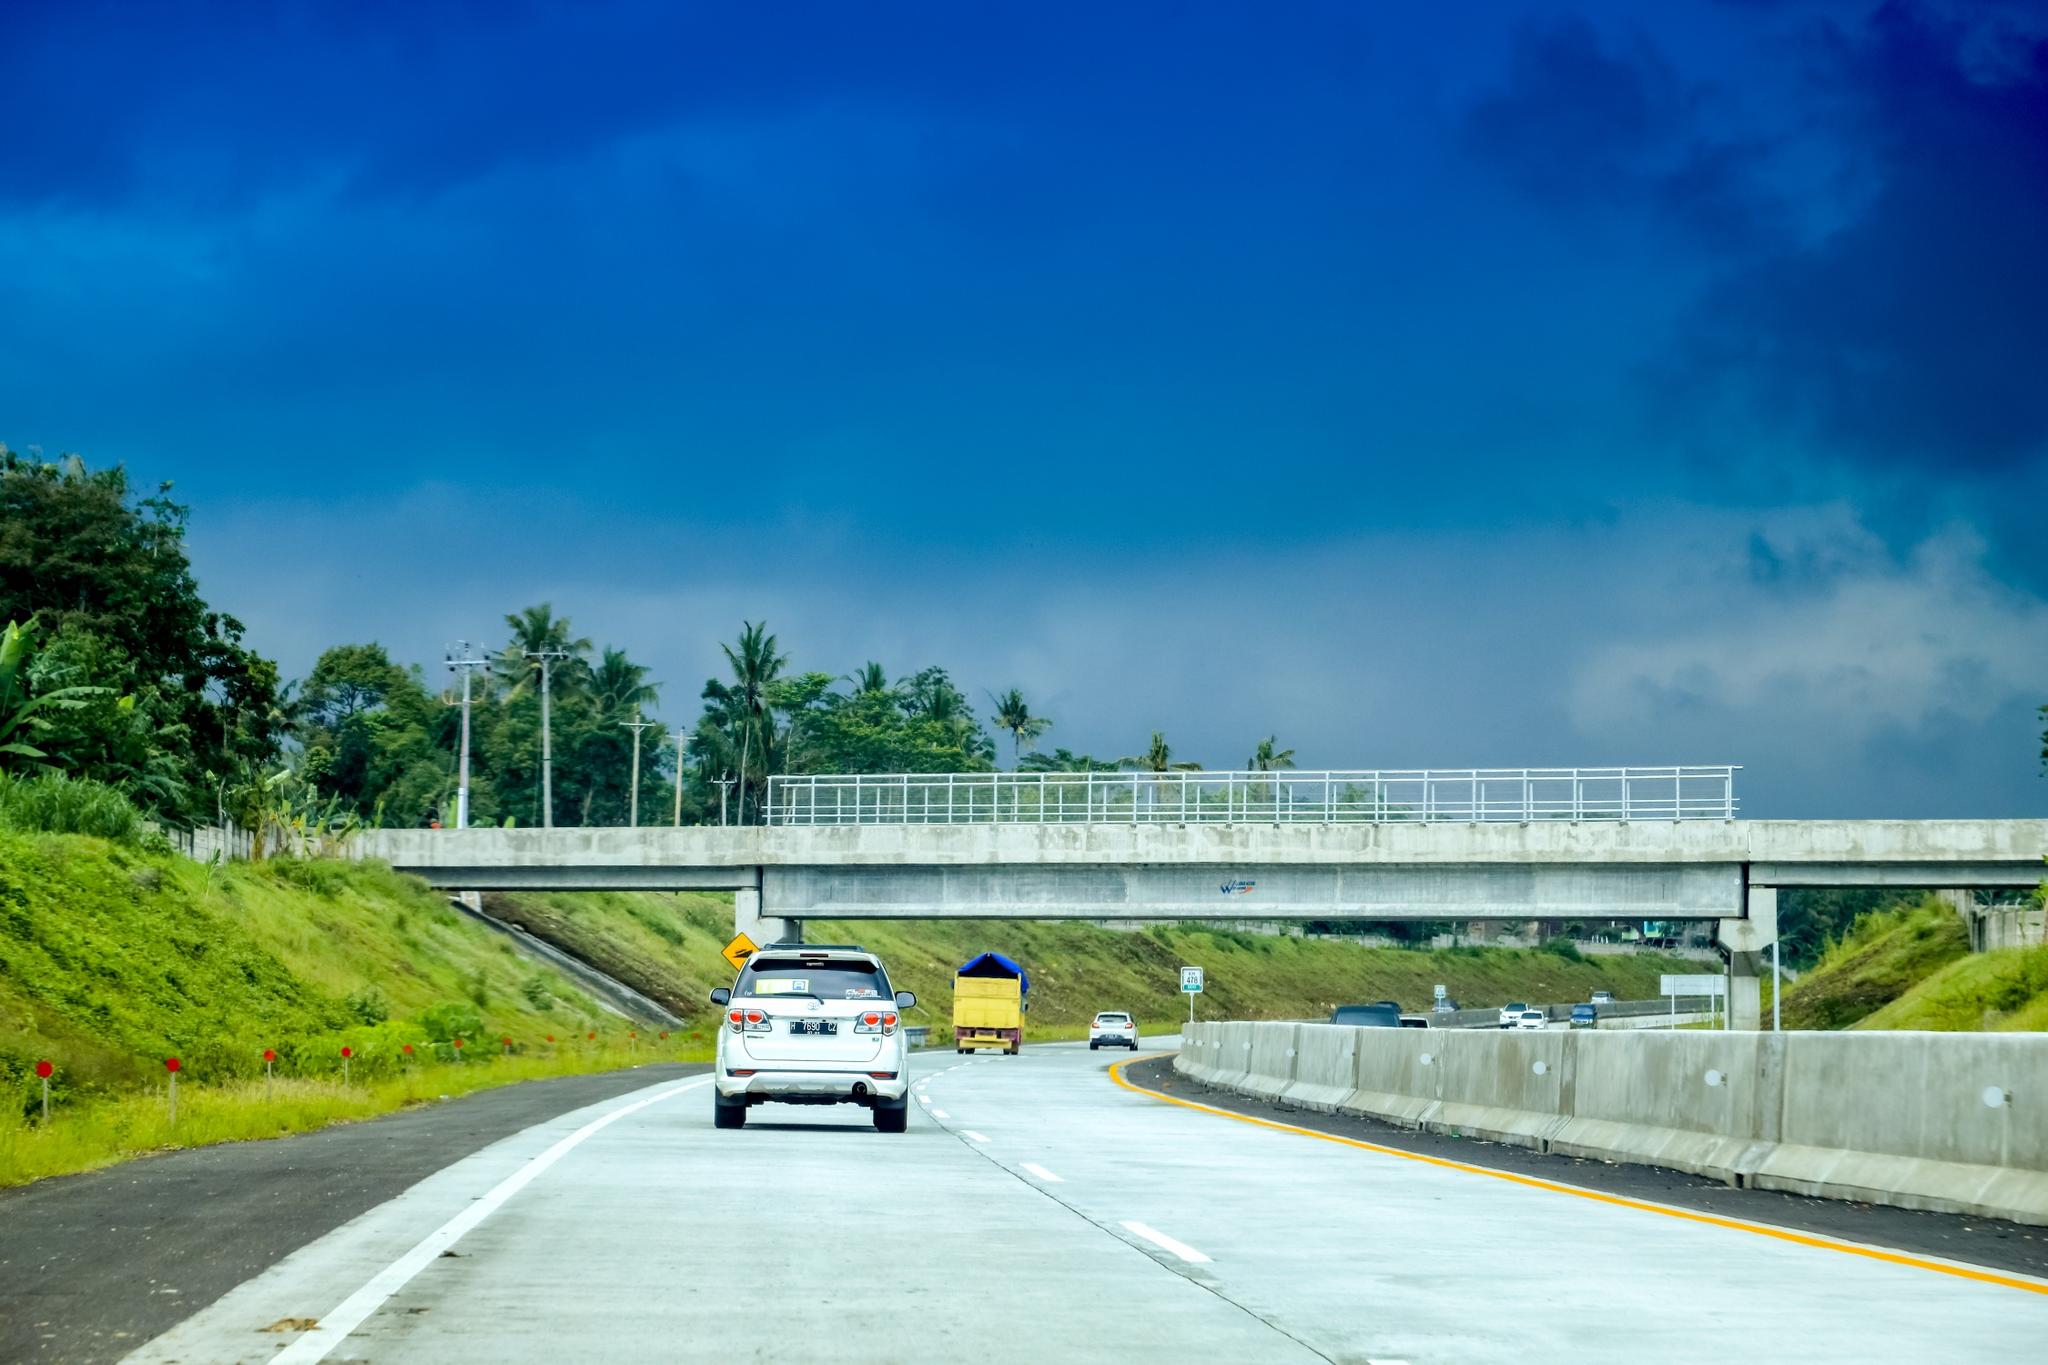If this image could talk, what tale might it share? In the dawn of modern roads, I emerged from the earth to connect lands and bridge hearts. I’ve witnessed countless journeys, each unique but woven from similar threads of adventure, purpose, and discovery. I recall the laughter of families on road trips, the silent contemplations of solo travelers, and the intricate choreography of nature that dances along my edges. Through sun and rain, I have remained steadfast, a canvas for life's countless stories — from joyous reunions to bittersweet farewells. Today, I am as much a part of the landscape as the trees that line me, a silent guardian of the myriad tales that pass over my surface. 